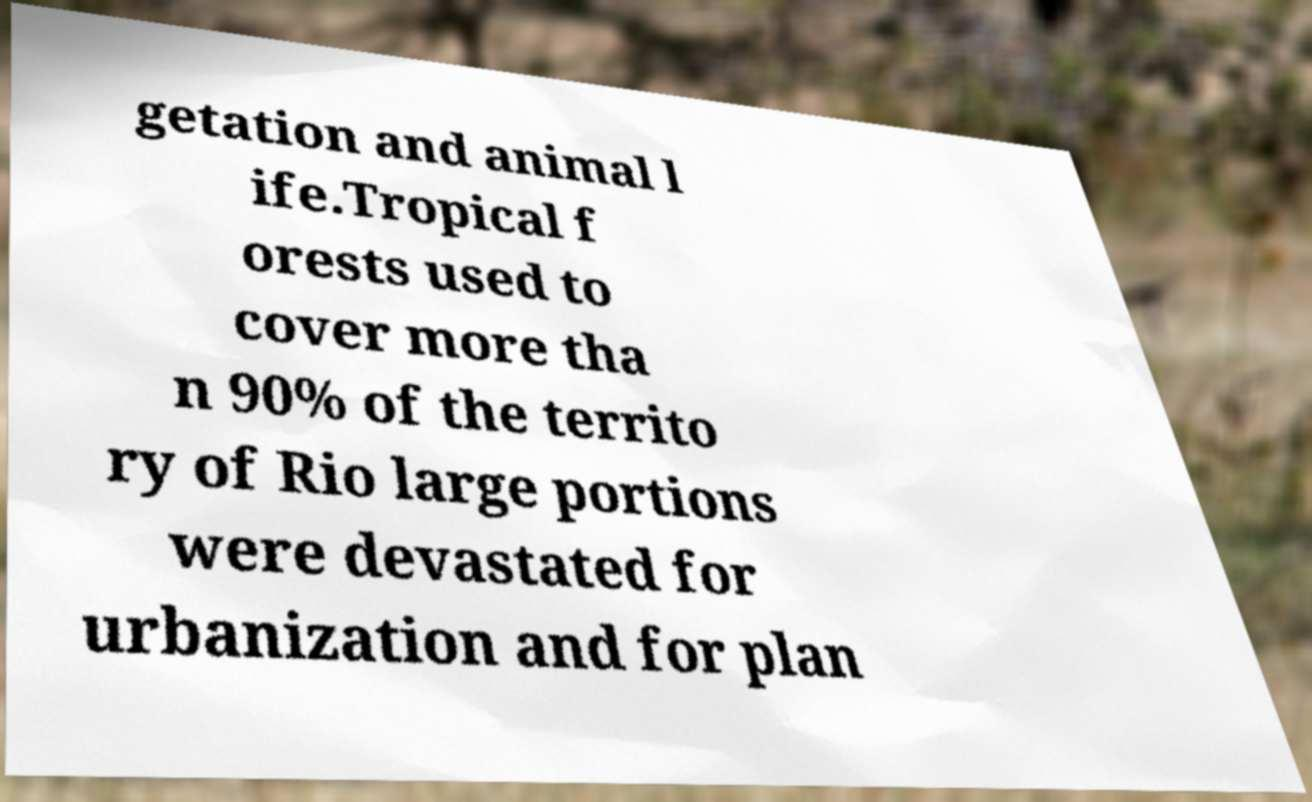Can you read and provide the text displayed in the image?This photo seems to have some interesting text. Can you extract and type it out for me? getation and animal l ife.Tropical f orests used to cover more tha n 90% of the territo ry of Rio large portions were devastated for urbanization and for plan 